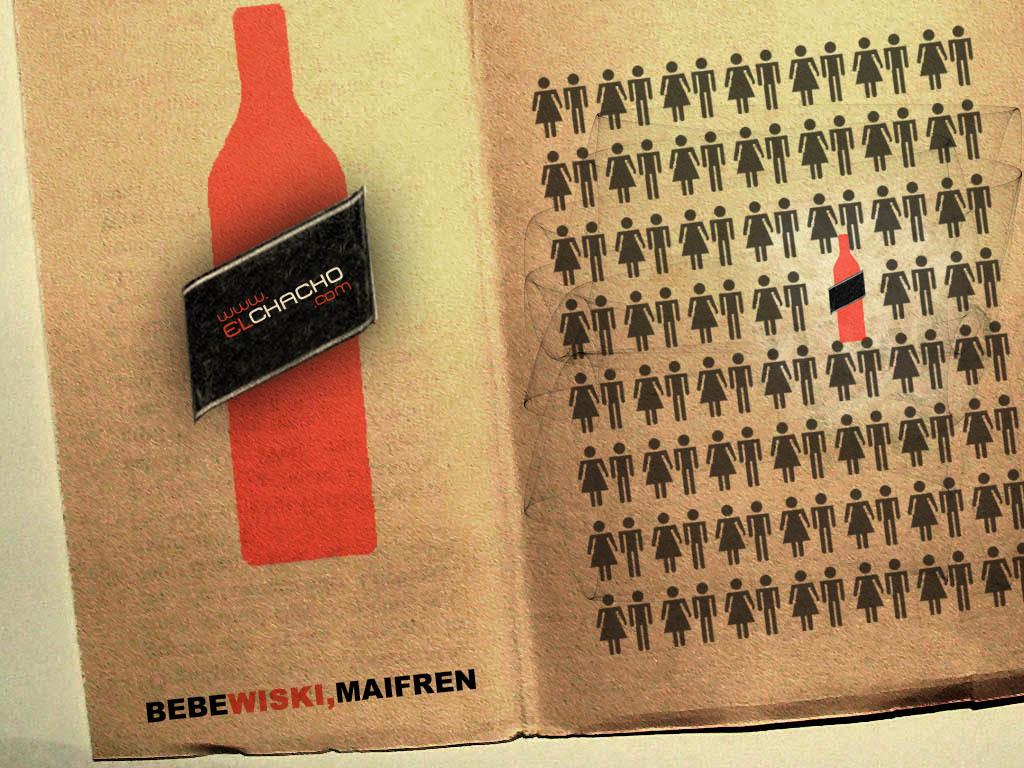<image>
Offer a succinct explanation of the picture presented. A red bottle of Elchacho and figures of males and females on the right 